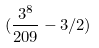<formula> <loc_0><loc_0><loc_500><loc_500>( \frac { 3 ^ { 8 } } { 2 0 9 } - 3 / 2 )</formula> 